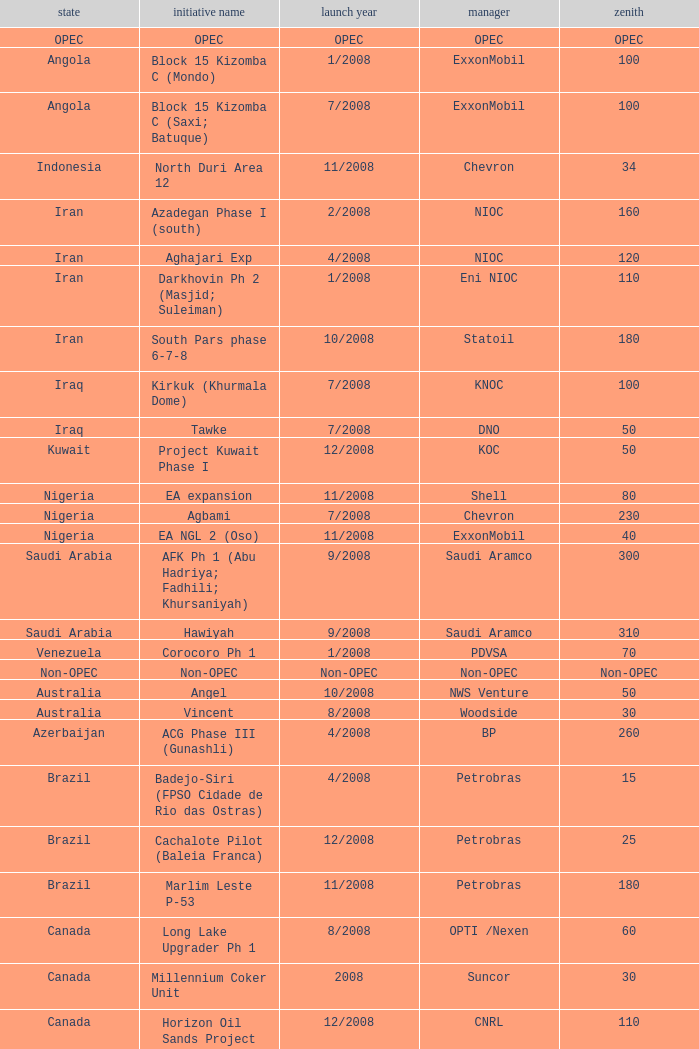What is the project identifier for a nation within opec? OPEC. 